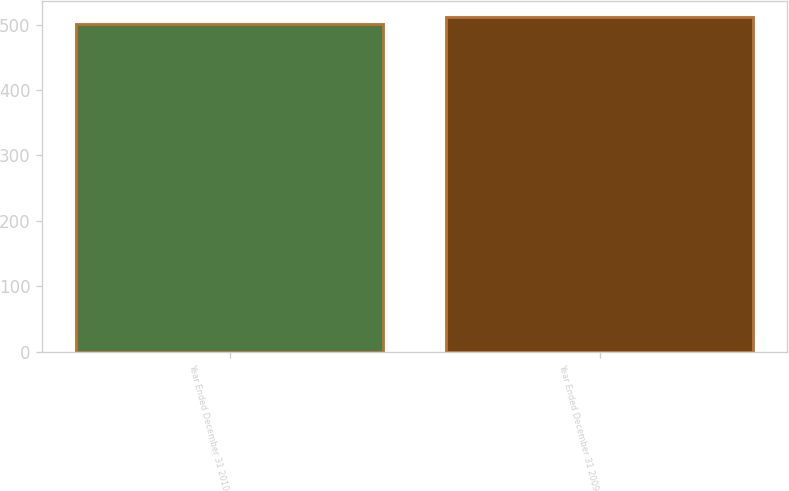Convert chart to OTSL. <chart><loc_0><loc_0><loc_500><loc_500><bar_chart><fcel>Year Ended December 31 2010<fcel>Year Ended December 31 2009<nl><fcel>501<fcel>511<nl></chart> 